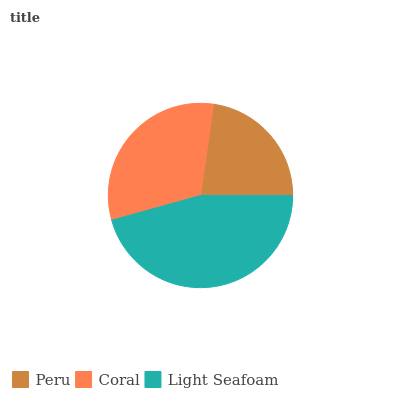Is Peru the minimum?
Answer yes or no. Yes. Is Light Seafoam the maximum?
Answer yes or no. Yes. Is Coral the minimum?
Answer yes or no. No. Is Coral the maximum?
Answer yes or no. No. Is Coral greater than Peru?
Answer yes or no. Yes. Is Peru less than Coral?
Answer yes or no. Yes. Is Peru greater than Coral?
Answer yes or no. No. Is Coral less than Peru?
Answer yes or no. No. Is Coral the high median?
Answer yes or no. Yes. Is Coral the low median?
Answer yes or no. Yes. Is Light Seafoam the high median?
Answer yes or no. No. Is Peru the low median?
Answer yes or no. No. 